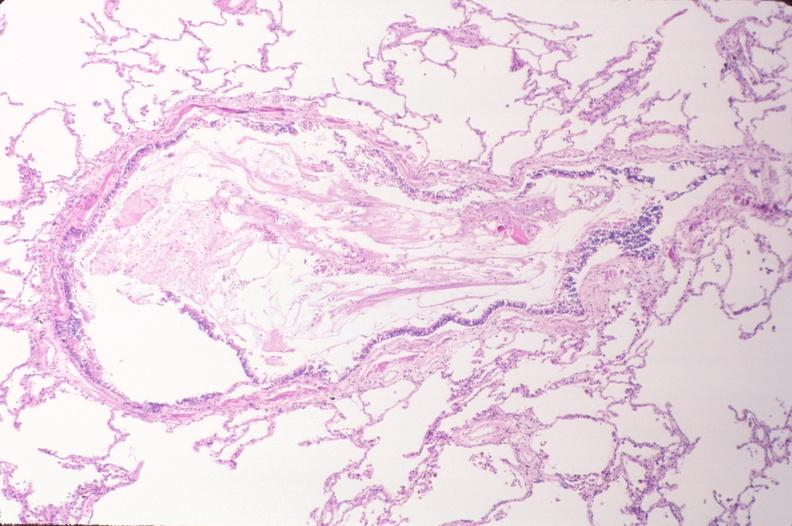does this image show lung, emphysema and bronchial plugging in a chronic smoker?
Answer the question using a single word or phrase. Yes 